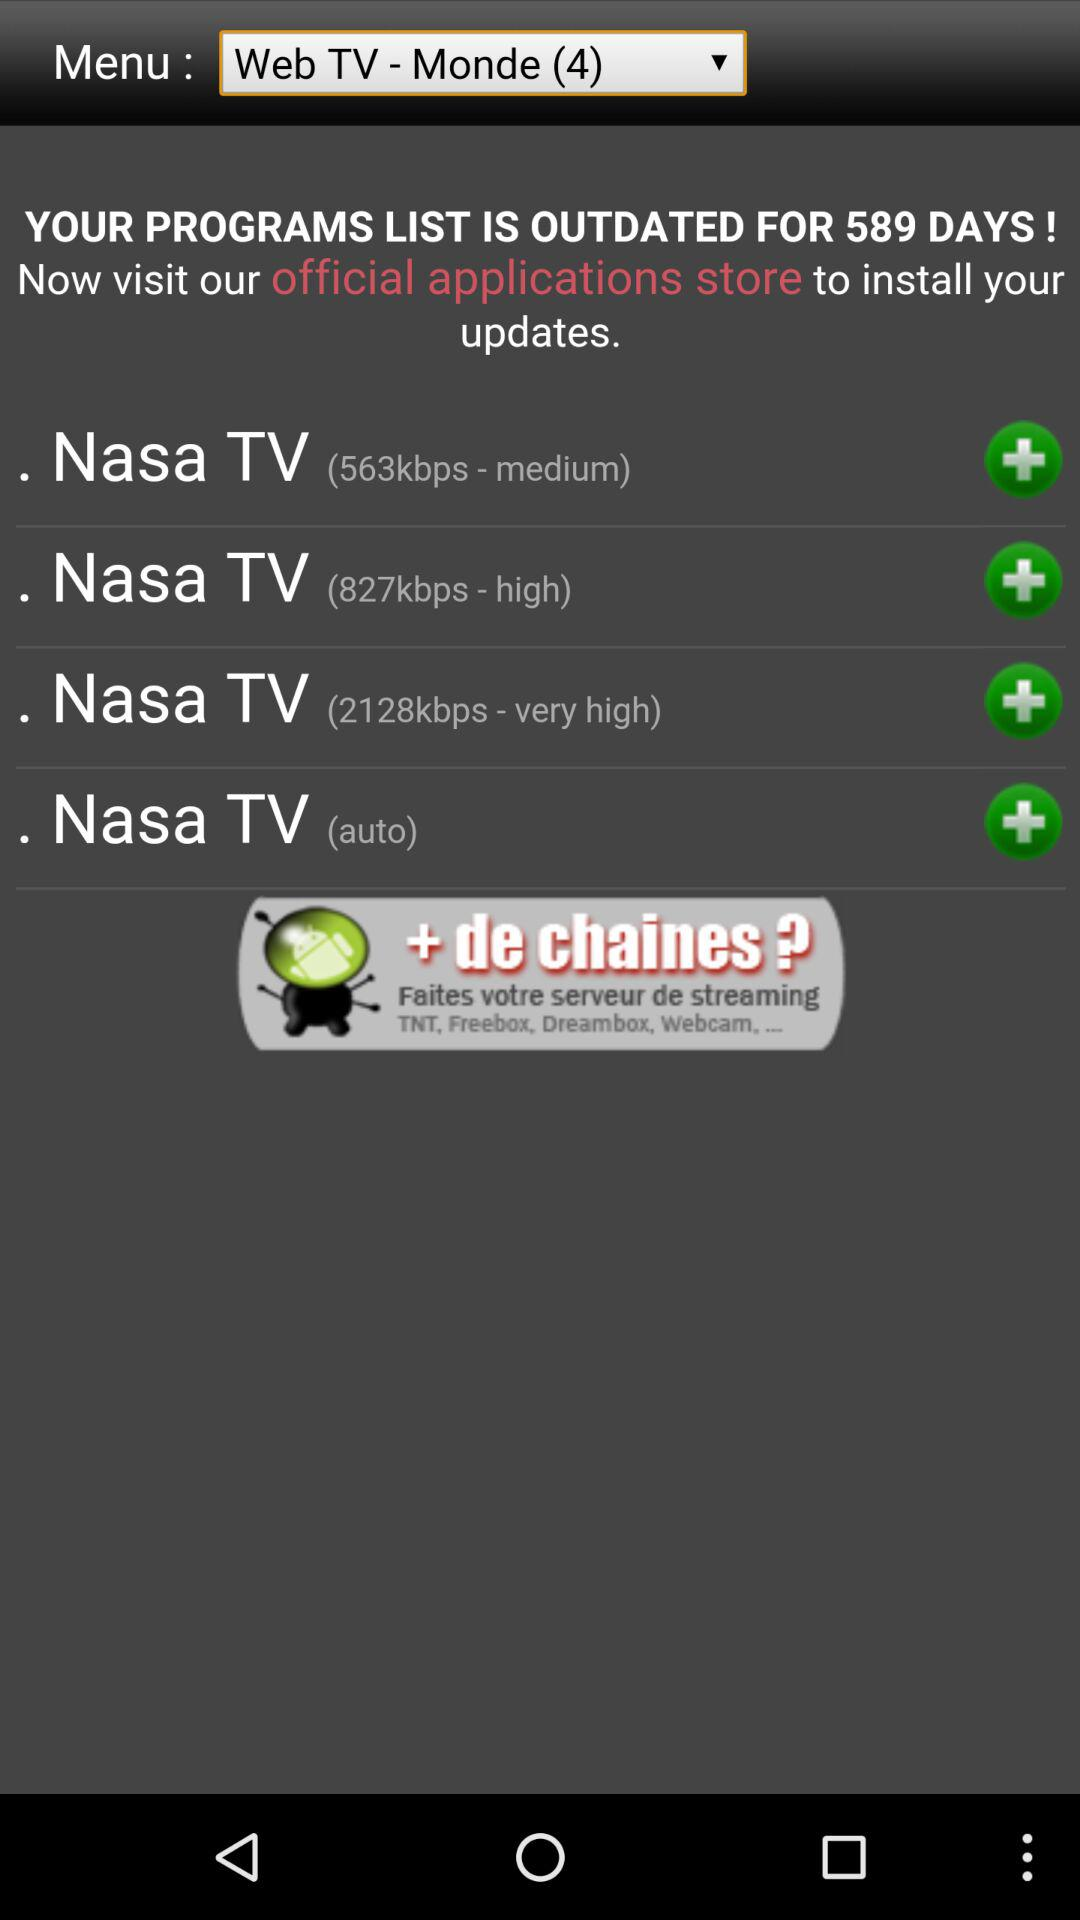For how many days is the programs list outdated? The programs list is outdated for 589 days. 